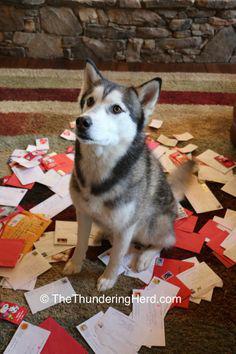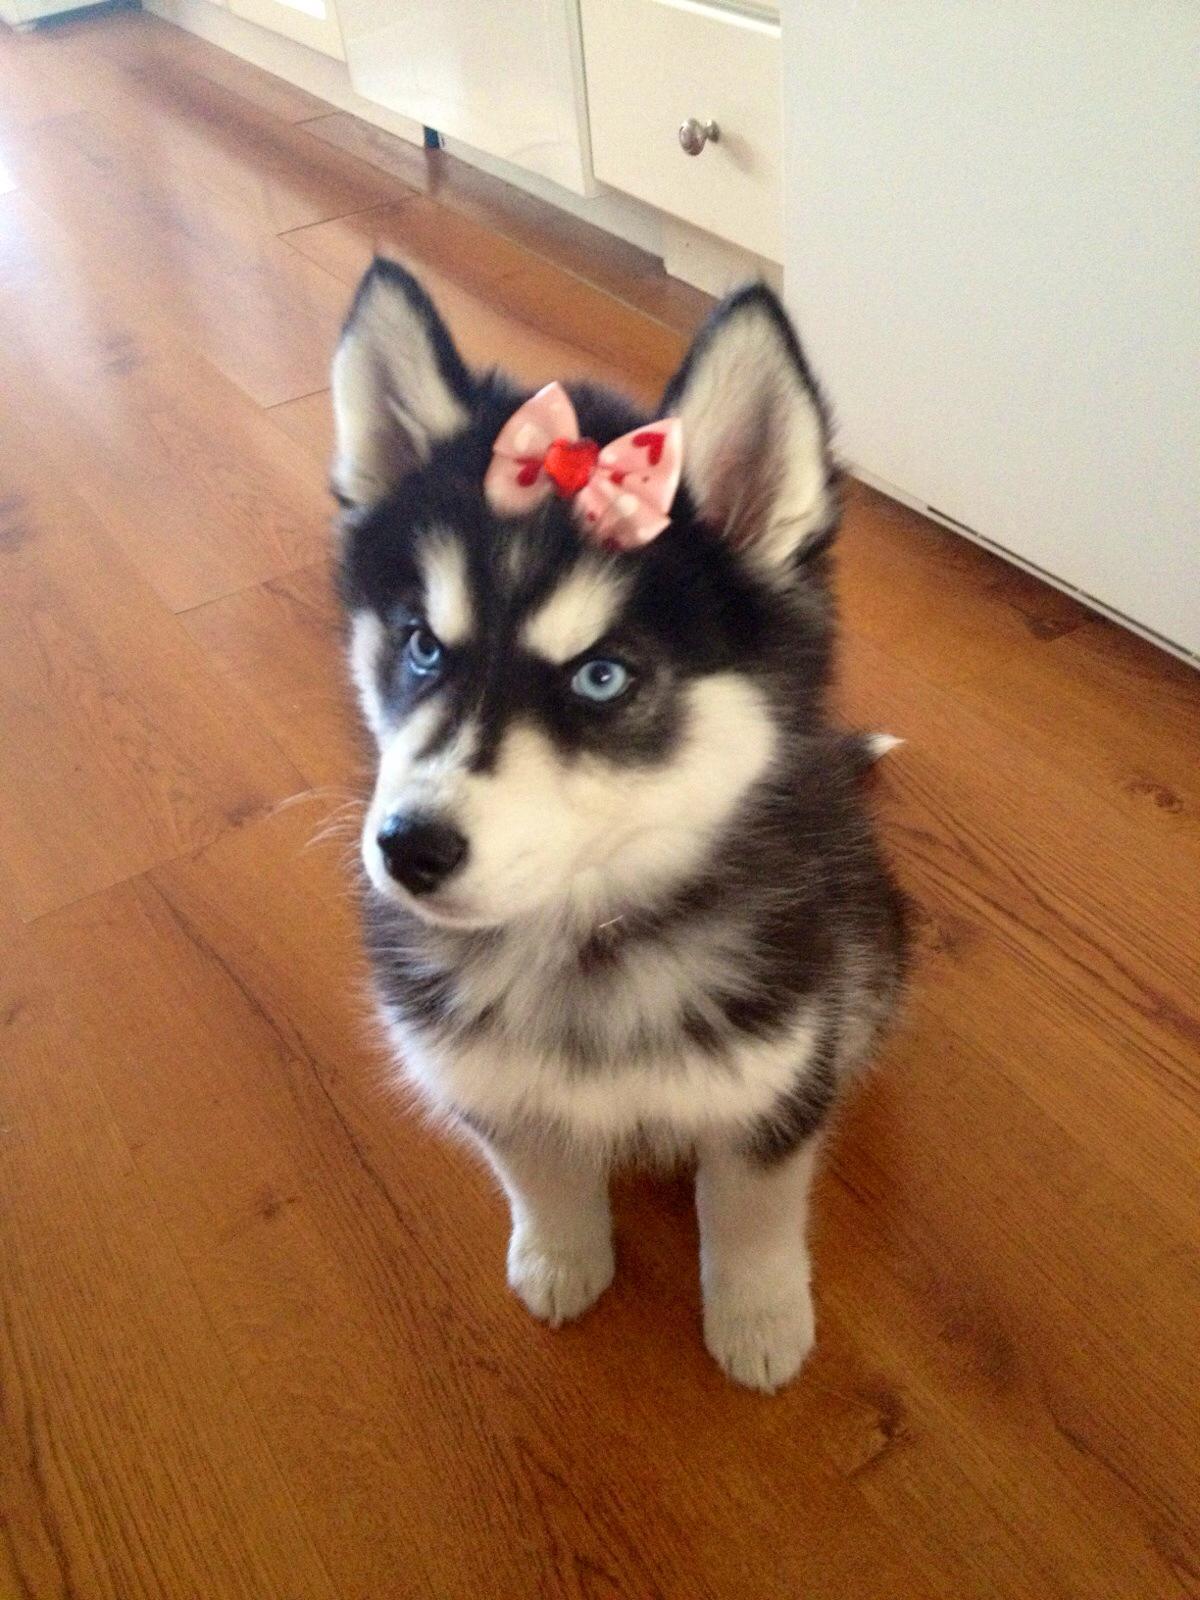The first image is the image on the left, the second image is the image on the right. Assess this claim about the two images: "The combined images include a dog wearing a bow,  at least one dog sitting upright, at least one dog looking upward, and something red on the floor in front of a dog.". Correct or not? Answer yes or no. Yes. The first image is the image on the left, the second image is the image on the right. Analyze the images presented: Is the assertion "Two dogs are sitting." valid? Answer yes or no. Yes. 